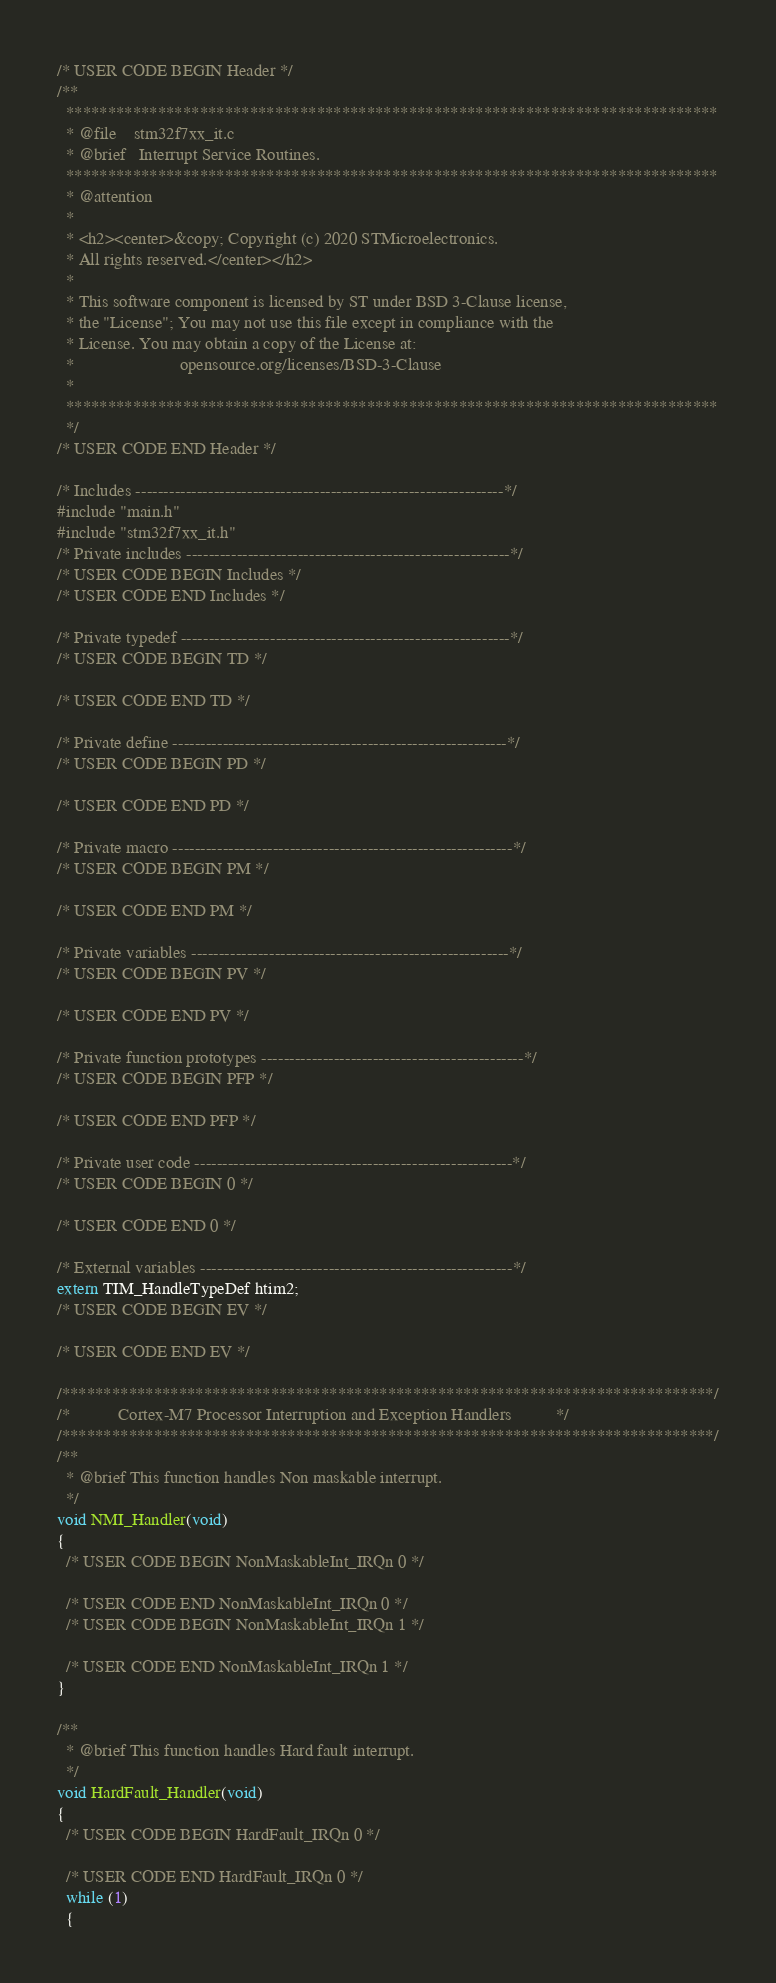<code> <loc_0><loc_0><loc_500><loc_500><_C_>/* USER CODE BEGIN Header */
/**
  ******************************************************************************
  * @file    stm32f7xx_it.c
  * @brief   Interrupt Service Routines.
  ******************************************************************************
  * @attention
  *
  * <h2><center>&copy; Copyright (c) 2020 STMicroelectronics.
  * All rights reserved.</center></h2>
  *
  * This software component is licensed by ST under BSD 3-Clause license,
  * the "License"; You may not use this file except in compliance with the
  * License. You may obtain a copy of the License at:
  *                        opensource.org/licenses/BSD-3-Clause
  *
  ******************************************************************************
  */
/* USER CODE END Header */

/* Includes ------------------------------------------------------------------*/
#include "main.h"
#include "stm32f7xx_it.h"
/* Private includes ----------------------------------------------------------*/
/* USER CODE BEGIN Includes */
/* USER CODE END Includes */

/* Private typedef -----------------------------------------------------------*/
/* USER CODE BEGIN TD */

/* USER CODE END TD */

/* Private define ------------------------------------------------------------*/
/* USER CODE BEGIN PD */
 
/* USER CODE END PD */

/* Private macro -------------------------------------------------------------*/
/* USER CODE BEGIN PM */

/* USER CODE END PM */

/* Private variables ---------------------------------------------------------*/
/* USER CODE BEGIN PV */

/* USER CODE END PV */

/* Private function prototypes -----------------------------------------------*/
/* USER CODE BEGIN PFP */

/* USER CODE END PFP */

/* Private user code ---------------------------------------------------------*/
/* USER CODE BEGIN 0 */

/* USER CODE END 0 */

/* External variables --------------------------------------------------------*/
extern TIM_HandleTypeDef htim2;
/* USER CODE BEGIN EV */

/* USER CODE END EV */

/******************************************************************************/
/*           Cortex-M7 Processor Interruption and Exception Handlers          */
/******************************************************************************/
/**
  * @brief This function handles Non maskable interrupt.
  */
void NMI_Handler(void)
{
  /* USER CODE BEGIN NonMaskableInt_IRQn 0 */

  /* USER CODE END NonMaskableInt_IRQn 0 */
  /* USER CODE BEGIN NonMaskableInt_IRQn 1 */

  /* USER CODE END NonMaskableInt_IRQn 1 */
}

/**
  * @brief This function handles Hard fault interrupt.
  */
void HardFault_Handler(void)
{
  /* USER CODE BEGIN HardFault_IRQn 0 */

  /* USER CODE END HardFault_IRQn 0 */
  while (1)
  {</code> 